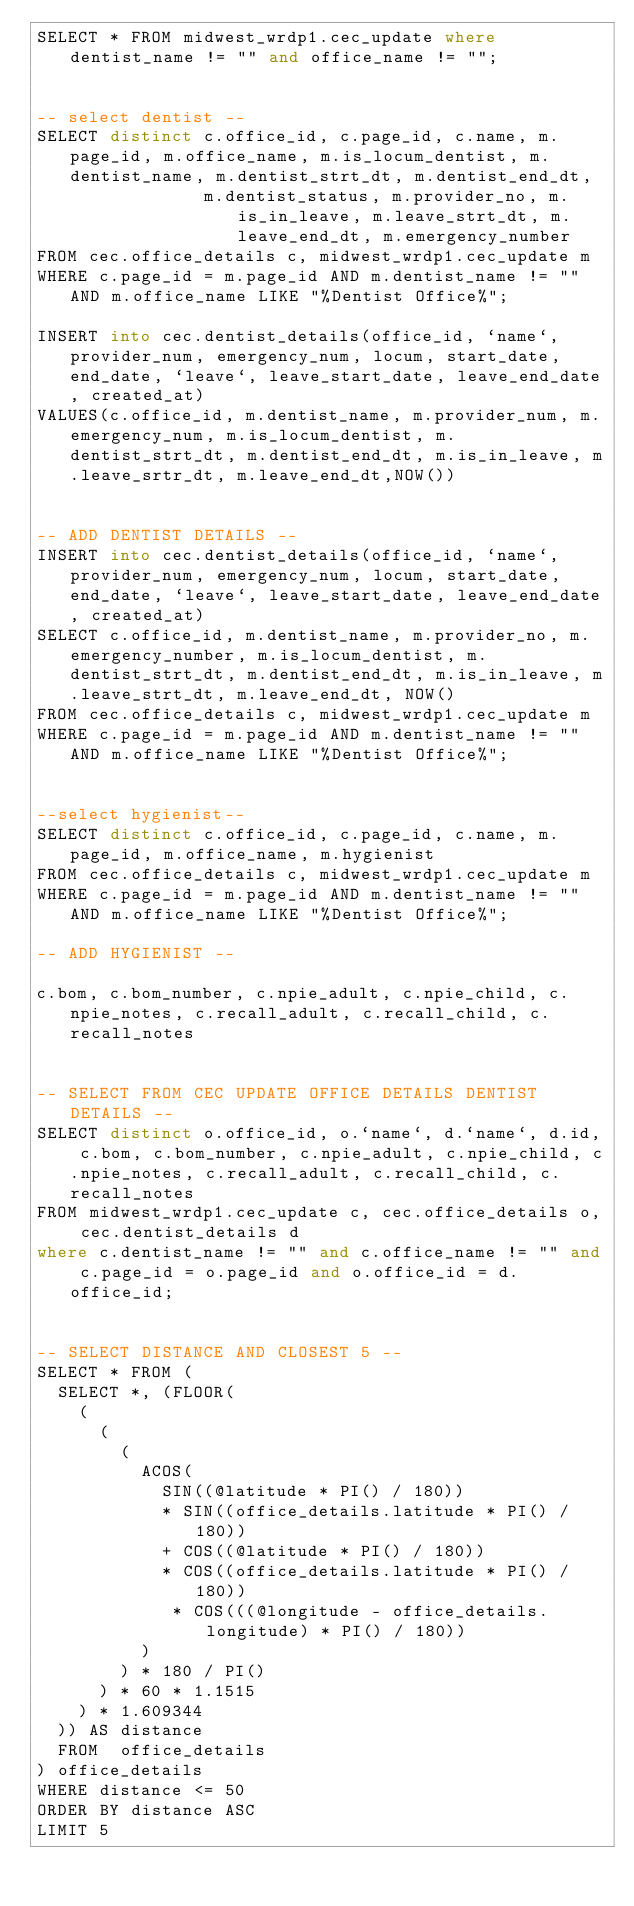Convert code to text. <code><loc_0><loc_0><loc_500><loc_500><_SQL_>SELECT * FROM midwest_wrdp1.cec_update where dentist_name != "" and office_name != "";


-- select dentist --
SELECT distinct c.office_id, c.page_id, c.name, m.page_id, m.office_name, m.is_locum_dentist, m.dentist_name, m.dentist_strt_dt, m.dentist_end_dt,
                m.dentist_status, m.provider_no, m.is_in_leave, m.leave_strt_dt, m.leave_end_dt, m.emergency_number
FROM cec.office_details c, midwest_wrdp1.cec_update m
WHERE c.page_id = m.page_id AND m.dentist_name != "" AND m.office_name LIKE "%Dentist Office%";

INSERT into cec.dentist_details(office_id, `name`, provider_num, emergency_num, locum, start_date, end_date, `leave`, leave_start_date, leave_end_date, created_at)
VALUES(c.office_id, m.dentist_name, m.provider_num, m.emergency_num, m.is_locum_dentist, m.dentist_strt_dt, m.dentist_end_dt, m.is_in_leave, m.leave_srtr_dt, m.leave_end_dt,NOW())


-- ADD DENTIST DETAILS --
INSERT into cec.dentist_details(office_id, `name`, provider_num, emergency_num, locum, start_date, end_date, `leave`, leave_start_date, leave_end_date, created_at)
SELECT c.office_id, m.dentist_name, m.provider_no, m.emergency_number, m.is_locum_dentist, m.dentist_strt_dt, m.dentist_end_dt, m.is_in_leave, m.leave_strt_dt, m.leave_end_dt, NOW()
FROM cec.office_details c, midwest_wrdp1.cec_update m
WHERE c.page_id = m.page_id AND m.dentist_name != "" AND m.office_name LIKE "%Dentist Office%";


--select hygienist--
SELECT distinct c.office_id, c.page_id, c.name, m.page_id, m.office_name, m.hygienist
FROM cec.office_details c, midwest_wrdp1.cec_update m
WHERE c.page_id = m.page_id AND m.dentist_name != "" AND m.office_name LIKE "%Dentist Office%";

-- ADD HYGIENIST --

c.bom, c.bom_number, c.npie_adult, c.npie_child, c.npie_notes, c.recall_adult, c.recall_child, c.recall_notes


-- SELECT FROM CEC UPDATE OFFICE DETAILS DENTIST DETAILS --
SELECT distinct o.office_id, o.`name`, d.`name`, d.id, c.bom, c.bom_number, c.npie_adult, c.npie_child, c.npie_notes, c.recall_adult, c.recall_child, c.recall_notes
FROM midwest_wrdp1.cec_update c, cec.office_details o, cec.dentist_details d
where c.dentist_name != "" and c.office_name != "" and c.page_id = o.page_id and o.office_id = d.office_id;


-- SELECT DISTANCE AND CLOSEST 5 --
SELECT * FROM (
  SELECT *, (FLOOR(
    (
      (
        (
          ACOS(
            SIN((@latitude * PI() / 180))
            * SIN((office_details.latitude * PI() / 180))
            + COS((@latitude * PI() / 180))
            * COS((office_details.latitude * PI() / 180))
             * COS(((@longitude - office_details.longitude) * PI() / 180))
          )
        ) * 180 / PI()
      ) * 60 * 1.1515
    ) * 1.609344
  )) AS distance
  FROM  office_details
) office_details
WHERE distance <= 50
ORDER BY distance ASC
LIMIT 5
</code> 